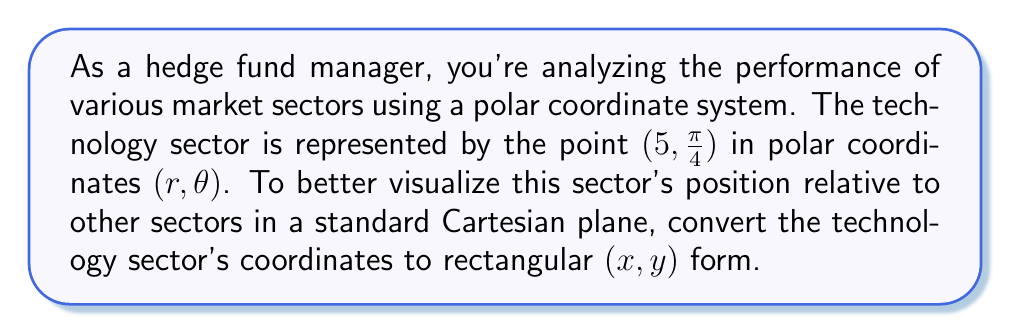Show me your answer to this math problem. To convert polar coordinates $(r, \theta)$ to Cartesian coordinates $(x, y)$, we use the following formulas:

$$x = r \cos(\theta)$$
$$y = r \sin(\theta)$$

Given:
$r = 5$
$\theta = \frac{\pi}{4}$

Step 1: Calculate x-coordinate
$$x = r \cos(\theta)$$
$$x = 5 \cos(\frac{\pi}{4})$$

We know that $\cos(\frac{\pi}{4}) = \frac{\sqrt{2}}{2}$, so:

$$x = 5 \cdot \frac{\sqrt{2}}{2} = \frac{5\sqrt{2}}{2}$$

Step 2: Calculate y-coordinate
$$y = r \sin(\theta)$$
$$y = 5 \sin(\frac{\pi}{4})$$

We know that $\sin(\frac{\pi}{4}) = \frac{\sqrt{2}}{2}$, so:

$$y = 5 \cdot \frac{\sqrt{2}}{2} = \frac{5\sqrt{2}}{2}$$

Therefore, the Cartesian coordinates of the technology sector are $(\frac{5\sqrt{2}}{2}, \frac{5\sqrt{2}}{2})$.

[asy]
import geometry;

size(200);
real r = 5;
real theta = pi/4;

draw((-6,0)--(6,0),Arrow);
draw((0,-6)--(0,6),Arrow);

dot((r*cos(theta),r*sin(theta)),red);
label("Technology Sector",(r*cos(theta),r*sin(theta)),NE);

draw((0,0)--(r*cos(theta),r*sin(theta)),dashed);
draw(arc((0,0),1,0,degrees(theta)),Arrow);
label("$\frac{\pi}{4}$",(0.7,0.3),NE);
label("5",(r*cos(theta)/2,r*sin(theta)/2),NW);

label("x",(-6,0),SW);
label("y",(0,6),NW);
[/asy]
Answer: $(\frac{5\sqrt{2}}{2}, \frac{5\sqrt{2}}{2})$ 